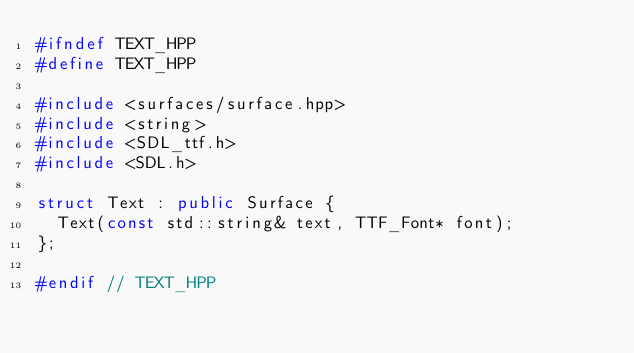<code> <loc_0><loc_0><loc_500><loc_500><_C++_>#ifndef TEXT_HPP
#define TEXT_HPP

#include <surfaces/surface.hpp>
#include <string>
#include <SDL_ttf.h>
#include <SDL.h>

struct Text : public Surface {
  Text(const std::string& text, TTF_Font* font);
};

#endif // TEXT_HPP
</code> 